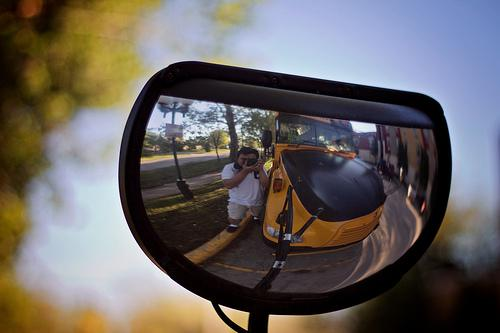Question: what is the man standing on?
Choices:
A. A skateboard.
B. A surf board.
C. A trampoline.
D. The curb.
Answer with the letter. Answer: D Question: where is the man?
Choices:
A. In the photograph.
B. In the reflection.
C. On a boat.
D. In the water.
Answer with the letter. Answer: B Question: what colors are the bus?
Choices:
A. Yellow and brown.
B. Red and white.
C. Yellow and black.
D. Black and white.
Answer with the letter. Answer: A Question: what color is the man's shirt?
Choices:
A. White.
B. Red.
C. Blue.
D. Brown.
Answer with the letter. Answer: A Question: what color are the man's shoes?
Choices:
A. Brown.
B. White.
C. Tan.
D. Black.
Answer with the letter. Answer: D 